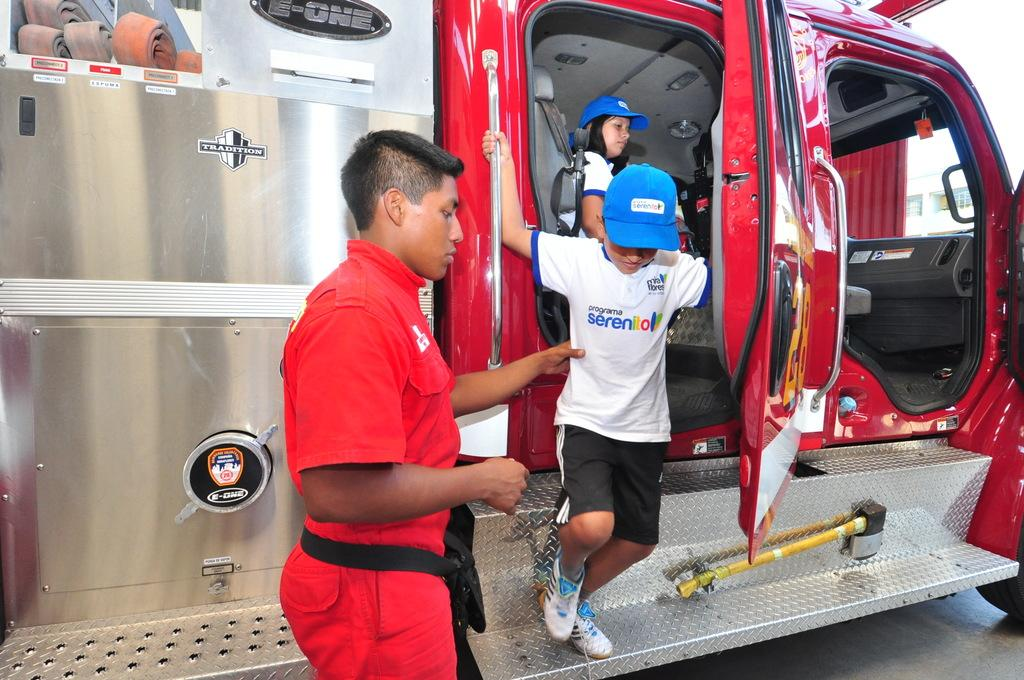How many people are in the image? There are people in the image, but the exact number is not specified. What are some people wearing in the image? Some people are wearing caps in the image. Where are some people located in the image? Some people are inside a vehicle in the image. What is a feature visible on the vehicle in the image? There is a side mirror visible in the image. What object can be seen in the image that is used for support or leverage? There is a rod in the image. What architectural feature is present in the image? There are steps in the image. What tool can be seen in the image? There is an axe in the image. What grade did the kitty receive on its report card in the image? There is no kitty or report card present in the image. What type of vacation is being planned by the people in the image? There is no indication of a vacation being planned in the image. 